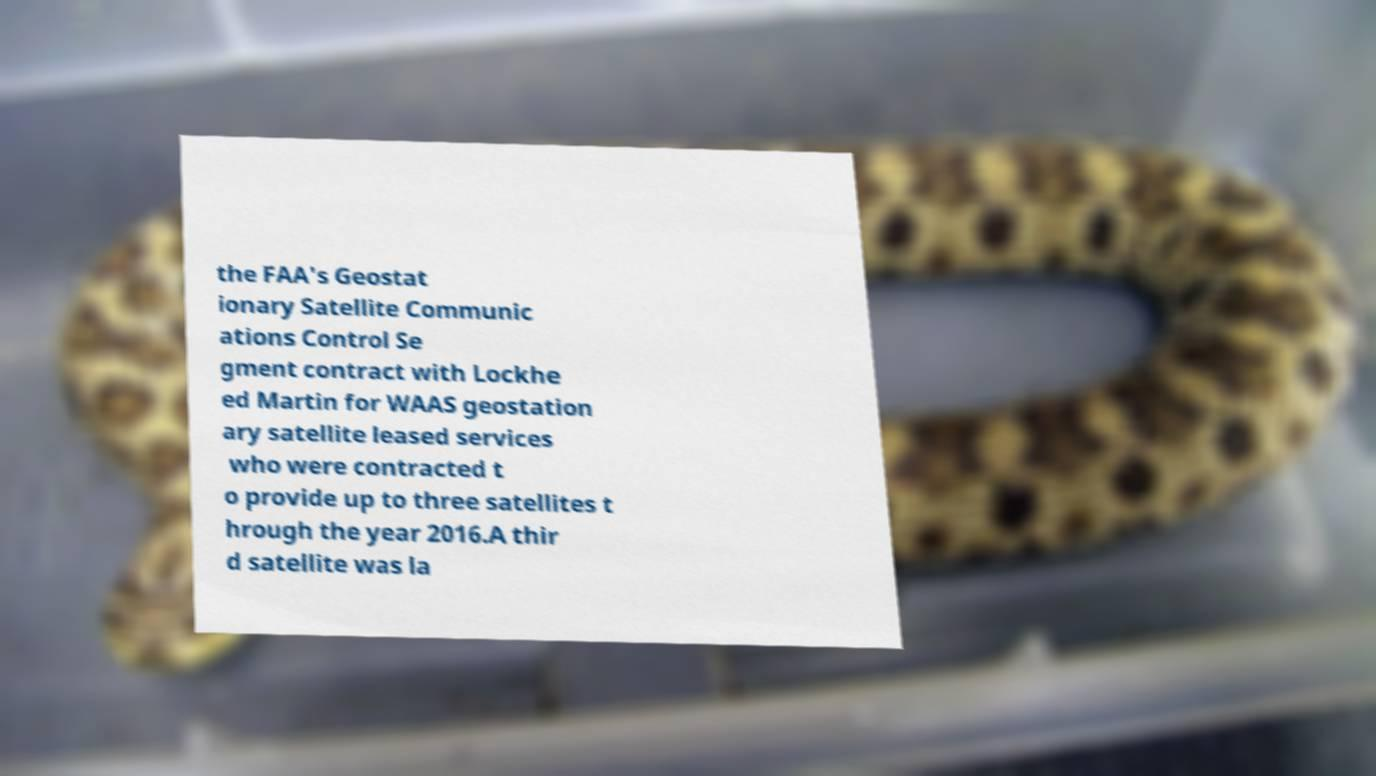For documentation purposes, I need the text within this image transcribed. Could you provide that? the FAA's Geostat ionary Satellite Communic ations Control Se gment contract with Lockhe ed Martin for WAAS geostation ary satellite leased services who were contracted t o provide up to three satellites t hrough the year 2016.A thir d satellite was la 